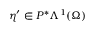<formula> <loc_0><loc_0><loc_500><loc_500>\eta ^ { \prime } \in P ^ { \ast } \Lambda ^ { 1 } ( \Omega )</formula> 